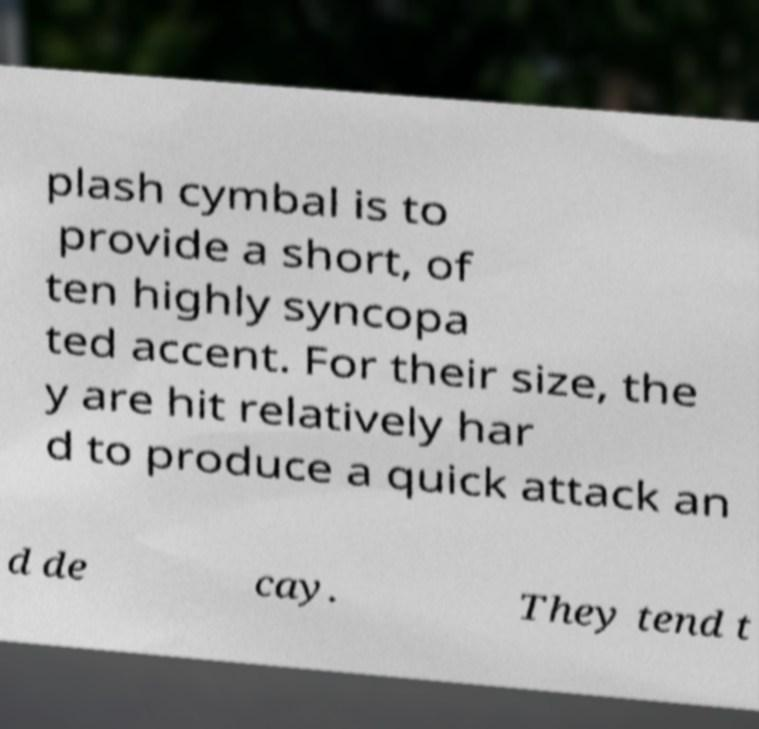Could you extract and type out the text from this image? plash cymbal is to provide a short, of ten highly syncopa ted accent. For their size, the y are hit relatively har d to produce a quick attack an d de cay. They tend t 